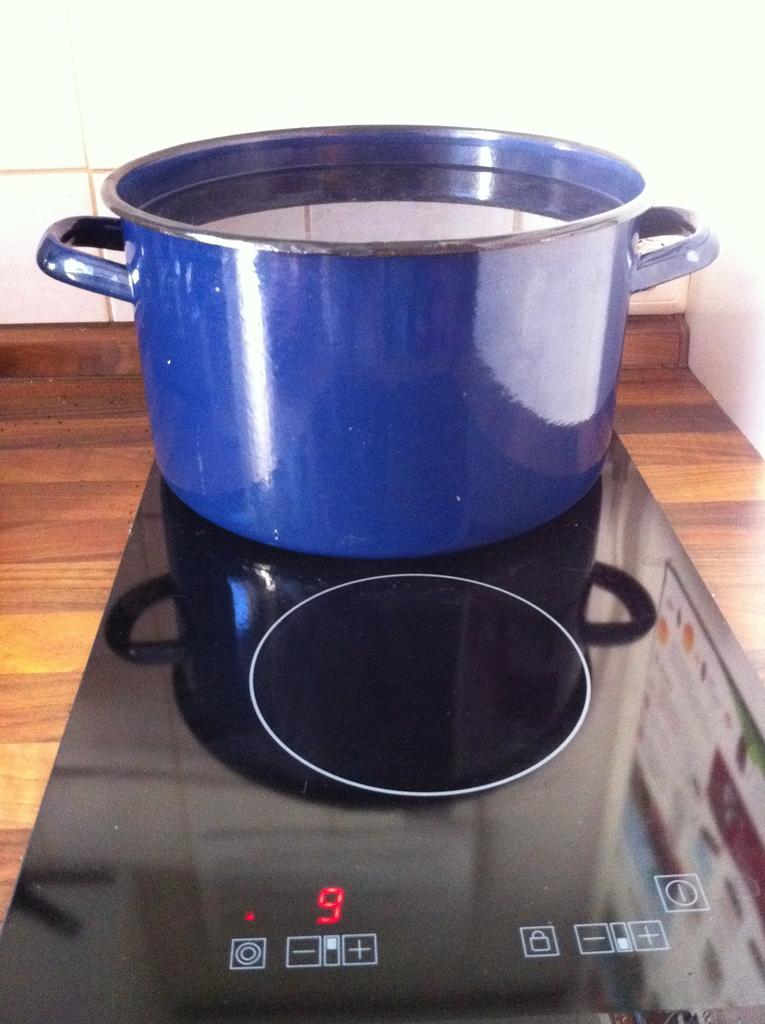What type of stove is shown in the image? There is an induction stove in the image. What is placed on the stove? There is a vessel filled with water on the stove. What color is the vessel? The vessel is blue in color. What other object can be seen in the image? There is a wooden board in the image. What is visible in the background of the image? There is a wall visible in the image. Can you describe the maid's attire in the image? There is no maid present in the image. 